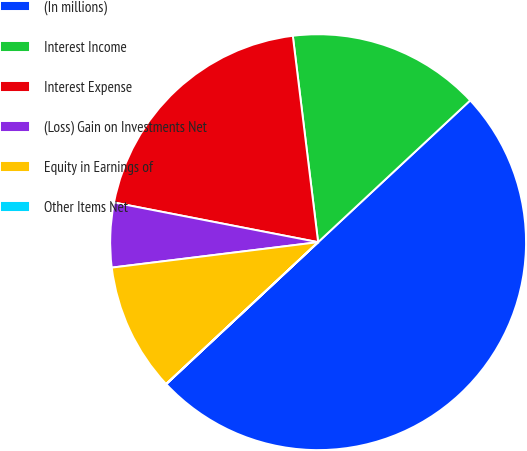Convert chart to OTSL. <chart><loc_0><loc_0><loc_500><loc_500><pie_chart><fcel>(In millions)<fcel>Interest Income<fcel>Interest Expense<fcel>(Loss) Gain on Investments Net<fcel>Equity in Earnings of<fcel>Other Items Net<nl><fcel>49.98%<fcel>15.0%<fcel>20.0%<fcel>5.01%<fcel>10.0%<fcel>0.01%<nl></chart> 